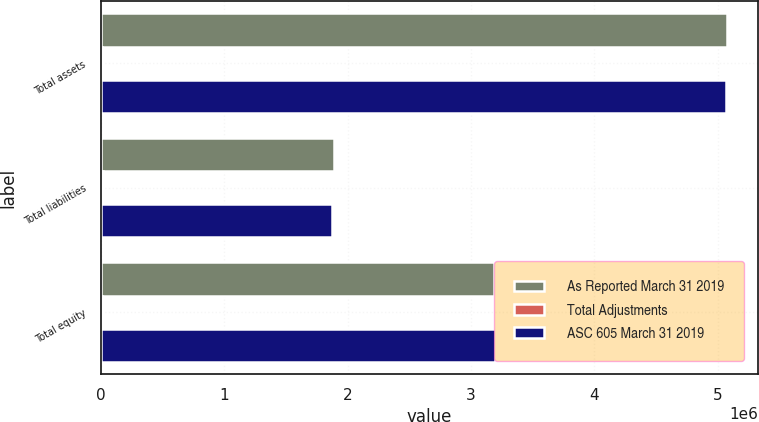Convert chart to OTSL. <chart><loc_0><loc_0><loc_500><loc_500><stacked_bar_chart><ecel><fcel>Total assets<fcel>Total liabilities<fcel>Total equity<nl><fcel>As Reported March 31 2019<fcel>5.07307e+06<fcel>1.88727e+06<fcel>3.1858e+06<nl><fcel>Total Adjustments<fcel>8429<fcel>14448<fcel>6019<nl><fcel>ASC 605 March 31 2019<fcel>5.06464e+06<fcel>1.87282e+06<fcel>3.19182e+06<nl></chart> 